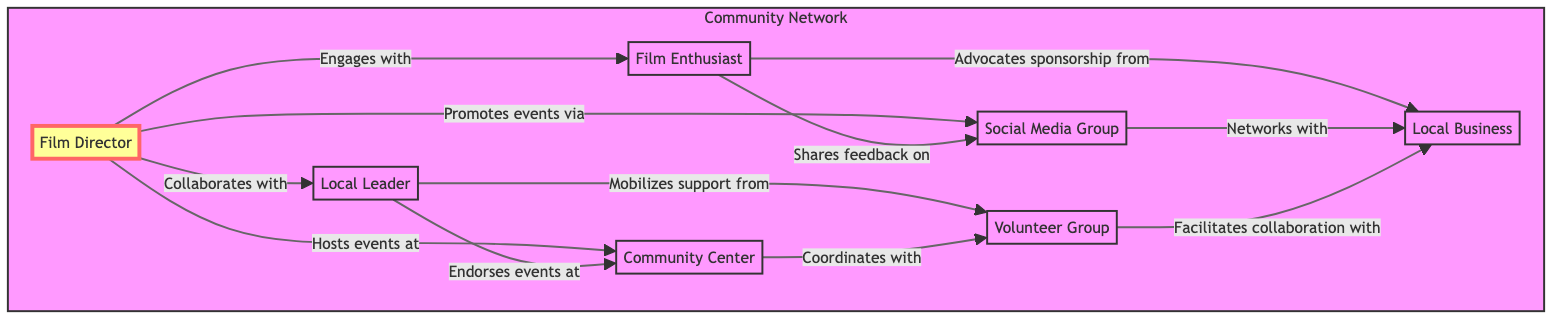What is the central role in the network? The central role in the network is represented by the Film Director, who is shown to have various interactions with other nodes. This can be identified as they are the only node styled as a centerNode, indicating their significance in connecting to other community members.
Answer: Film Director How many nodes are present in the diagram? The diagram consists of seven distinct nodes: Film Director, Local Leader, Film Enthusiast, Community Center, Social Media Group, Local Business, and Volunteer Group. Each represents a different entity in the community network.
Answer: 7 Which node is connected to the Community Center for coordinating activities? The Volunteer Group is directly linked to the Community Center in the diagram, indicating that they work together to coordinate activities. This is reflected in the edge labeled "Coordinates with."
Answer: Volunteer Group What type of support does the Local Leader provide? The Local Leader is shown to mobilize support from the Volunteer Group according to the relationships illustrated. This means they play a role in influencing and organizing local volunteers for the support of film events.
Answer: Mobilizes support How does the Film Enthusiast contribute to sponsorship? The Film Enthusiast advocates for sponsorship from the Local Business, according to the directed edge in the diagram. This shows that they actively engage in seeking funding or support from local businesses for community film events.
Answer: Advocates sponsorship Which node directly promotes events via social media? The Film Director is depicted as promoting events through the Social Media Group. This relationship indicates how the director uses social media to enhance visibility and engagement for film-related events.
Answer: Social Media Group What is the relationship between the Local Business and the Social Media Group? The diagram illustrates a networking connection where the Local Business interacts with the Social Media Group, emphasizing the collaboration between local commerce and online platforms to promote events.
Answer: Networks with How does the Community Center relate to the Volunteer Group? The Community Center is shown to coordinate activities with the Volunteer Group, which implies a collaborative effort to plan and execute community events, highlighting their joint role in supporting local initiatives.
Answer: Coordinates with What action does the Film Director take at the Community Center? The Film Director hosts events at the Community Center as depicted in the diagram. This highlights their involvement in utilizing the community space for organizing film-related activities.
Answer: Hosts events at 